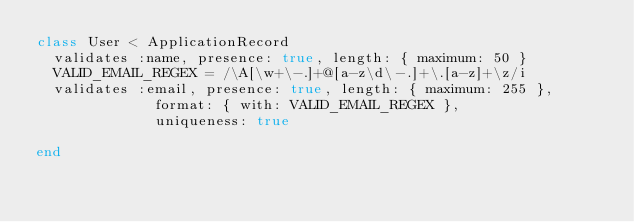Convert code to text. <code><loc_0><loc_0><loc_500><loc_500><_Ruby_>class User < ApplicationRecord
  validates :name, presence: true, length: { maximum: 50 }
  VALID_EMAIL_REGEX = /\A[\w+\-.]+@[a-z\d\-.]+\.[a-z]+\z/i
  validates :email, presence: true, length: { maximum: 255 },
              format: { with: VALID_EMAIL_REGEX },
              uniqueness: true

end
</code> 